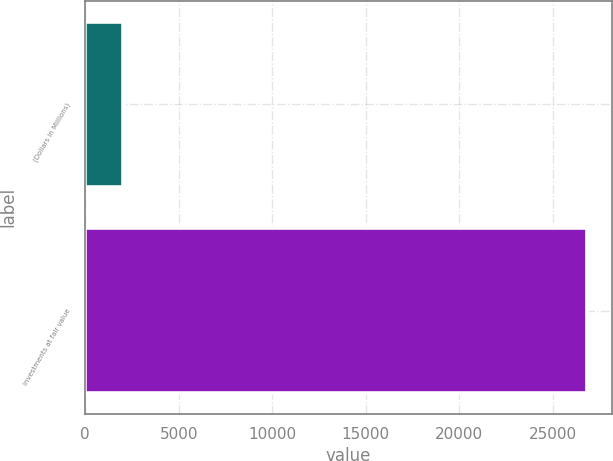Convert chart to OTSL. <chart><loc_0><loc_0><loc_500><loc_500><bar_chart><fcel>(Dollars in Millions)<fcel>Investments at fair value<nl><fcel>2018<fcel>26818<nl></chart> 